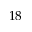<formula> <loc_0><loc_0><loc_500><loc_500>1 8</formula> 